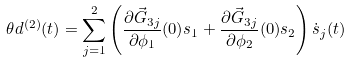<formula> <loc_0><loc_0><loc_500><loc_500>\theta d ^ { ( 2 ) } ( t ) = \sum _ { j = 1 } ^ { 2 } \left ( \frac { \partial \vec { G } _ { 3 j } } { \partial \phi _ { 1 } } ( 0 ) s _ { 1 } + \frac { \partial \vec { G } _ { 3 j } } { \partial \phi _ { 2 } } ( 0 ) s _ { 2 } \right ) \dot { s } _ { j } ( t )</formula> 